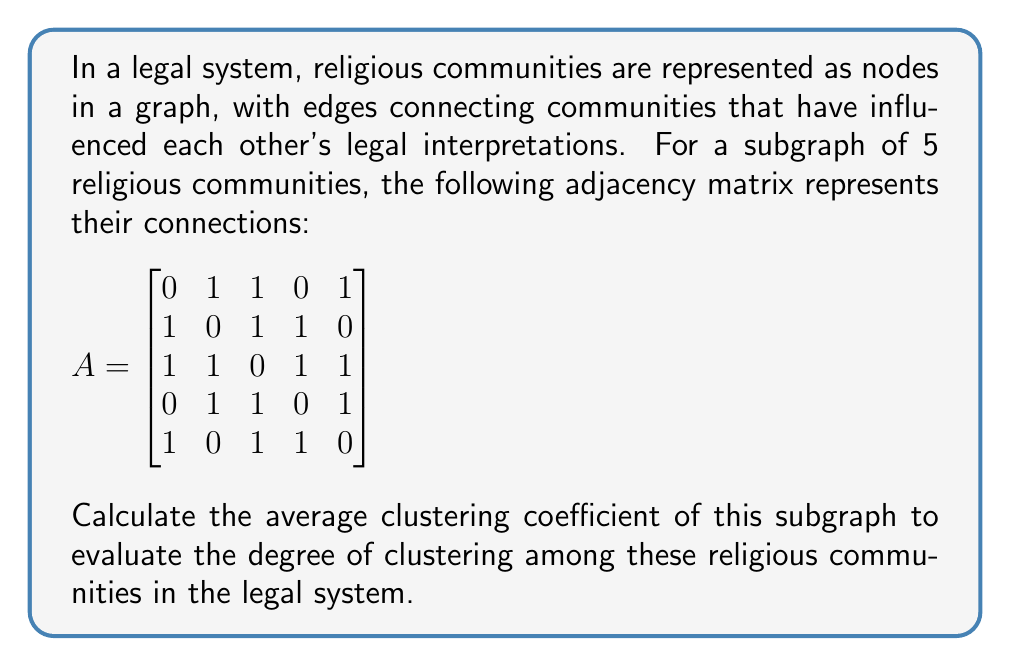Solve this math problem. To solve this problem, we'll follow these steps:

1) First, recall the formula for the clustering coefficient of a node $i$:

   $C_i = \frac{2L_i}{k_i(k_i-1)}$

   where $L_i$ is the number of links between the neighbors of node $i$, and $k_i$ is the degree of node $i$.

2) For each node, we need to:
   a) Determine its degree $k_i$
   b) Count the number of links between its neighbors $L_i$
   c) Calculate its clustering coefficient $C_i$

3) Finally, we'll take the average of all $C_i$ values.

Let's proceed node by node:

Node 1:
$k_1 = 3$, $L_1 = 2$
$C_1 = \frac{2(2)}{3(2)} = \frac{4}{6} = \frac{2}{3}$

Node 2:
$k_2 = 3$, $L_2 = 2$
$C_2 = \frac{2(2)}{3(2)} = \frac{4}{6} = \frac{2}{3}$

Node 3:
$k_3 = 4$, $L_3 = 4$
$C_3 = \frac{2(4)}{4(3)} = \frac{8}{12} = \frac{2}{3}$

Node 4:
$k_4 = 3$, $L_4 = 2$
$C_4 = \frac{2(2)}{3(2)} = \frac{4}{6} = \frac{2}{3}$

Node 5:
$k_5 = 3$, $L_5 = 2$
$C_5 = \frac{2(2)}{3(2)} = \frac{4}{6} = \frac{2}{3}$

4) Now, we calculate the average clustering coefficient:

   $C_{avg} = \frac{C_1 + C_2 + C_3 + C_4 + C_5}{5} = \frac{\frac{2}{3} + \frac{2}{3} + \frac{2}{3} + \frac{2}{3} + \frac{2}{3}}{5} = \frac{2}{3}$
Answer: The average clustering coefficient of the subgraph is $\frac{2}{3}$ or approximately $0.6667$. 